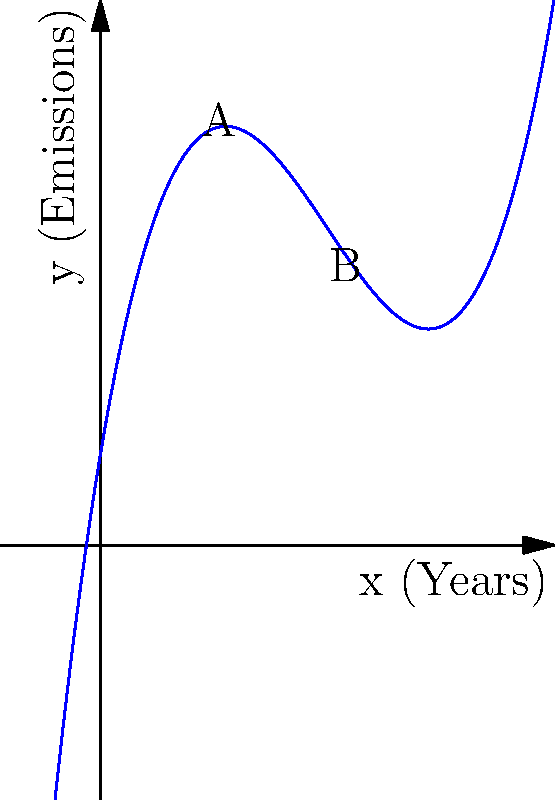The graph represents the environmental impact of industrial emissions over time, modeled by the polynomial function $f(x) = 0.1x^3 - 1.5x^2 + 6x + 2$, where $x$ represents years and $f(x)$ represents emission levels. As an environmentally conscious graphic designer, calculate the rate of change in emissions between points A (2 years) and B (6 years). Express your answer to two decimal places. To find the rate of change between points A and B:

1. Calculate $f(2)$ and $f(6)$:
   $f(2) = 0.1(2^3) - 1.5(2^2) + 6(2) + 2 = 0.8 - 6 + 12 + 2 = 8.8$
   $f(6) = 0.1(6^3) - 1.5(6^2) + 6(6) + 2 = 21.6 - 54 + 36 + 2 = 5.6$

2. Calculate the change in y (emissions):
   $\Delta y = f(6) - f(2) = 5.6 - 8.8 = -3.2$

3. Calculate the change in x (years):
   $\Delta x = 6 - 2 = 4$

4. Calculate the rate of change:
   Rate of change = $\frac{\Delta y}{\Delta x} = \frac{-3.2}{4} = -0.8$

The negative value indicates a decrease in emissions over time.
Answer: -0.80 